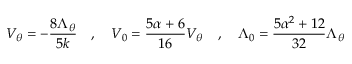<formula> <loc_0><loc_0><loc_500><loc_500>V _ { \theta } = - { \frac { 8 \Lambda _ { \theta } } { 5 k } } , V _ { 0 } = { \frac { 5 \alpha + 6 } { 1 6 } } V _ { \theta } , \Lambda _ { 0 } = { \frac { 5 \alpha ^ { 2 } + 1 2 } { 3 2 } } \Lambda _ { \theta }</formula> 